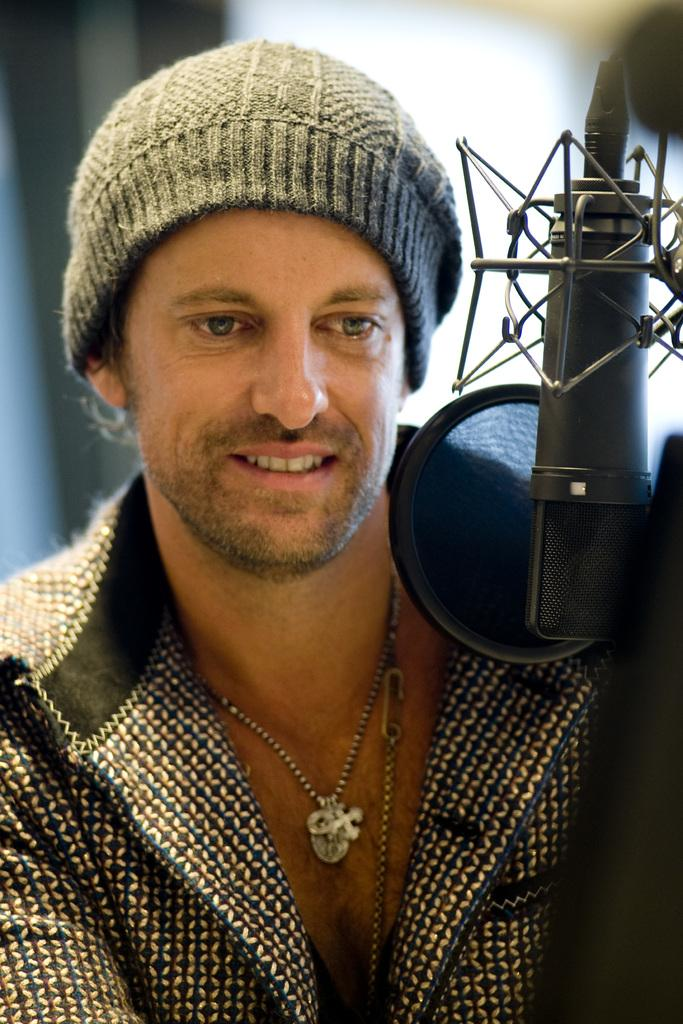Who is the main subject in the image? There is a man in the middle of the image. What is the man doing in the image? The man is standing in front of a mic. Can you describe the man's attire in the image? The man is wearing a cap and a chain. What type of sweater is the spy wearing in the image? There is no spy or sweater present in the image. 